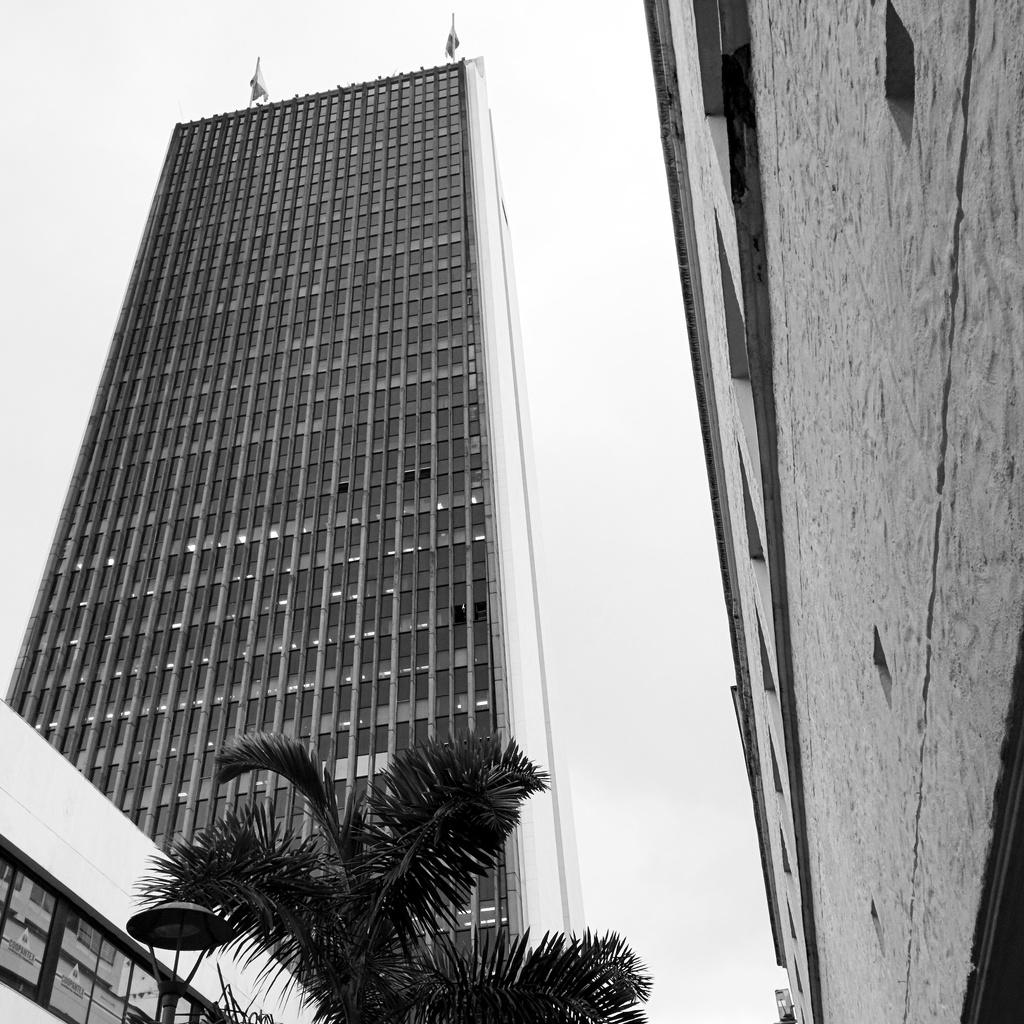What is the color scheme of the image? The image is black and white. What is the main structure in the image? There is a tall building in the image. What is located in front of the tall building? There is a tree in front of the tall building. What other building can be seen in the image? There is another building on the right side of the image. How many cattle can be seen grazing near the tall building in the image? There are no cattle present in the image. What type of vein is visible on the tree in the image? There are no veins visible on the tree in the image, as trees do not have veins like animals do. 